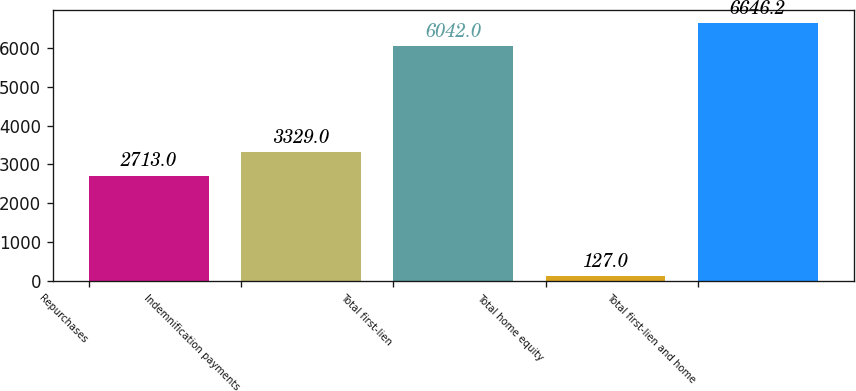<chart> <loc_0><loc_0><loc_500><loc_500><bar_chart><fcel>Repurchases<fcel>Indemnification payments<fcel>Total first-lien<fcel>Total home equity<fcel>Total first-lien and home<nl><fcel>2713<fcel>3329<fcel>6042<fcel>127<fcel>6646.2<nl></chart> 